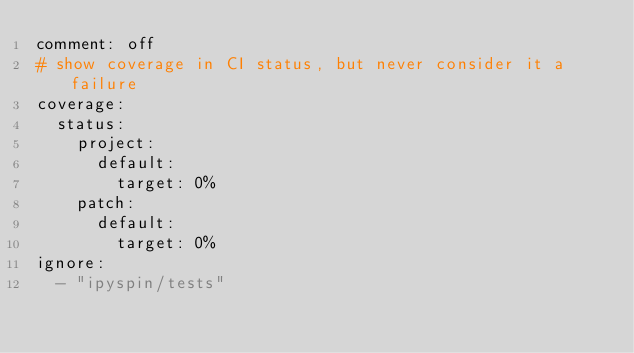<code> <loc_0><loc_0><loc_500><loc_500><_YAML_>comment: off
# show coverage in CI status, but never consider it a failure
coverage:
  status:
    project:
      default:
        target: 0%
    patch:
      default:
        target: 0%
ignore:
  - "ipyspin/tests"
</code> 